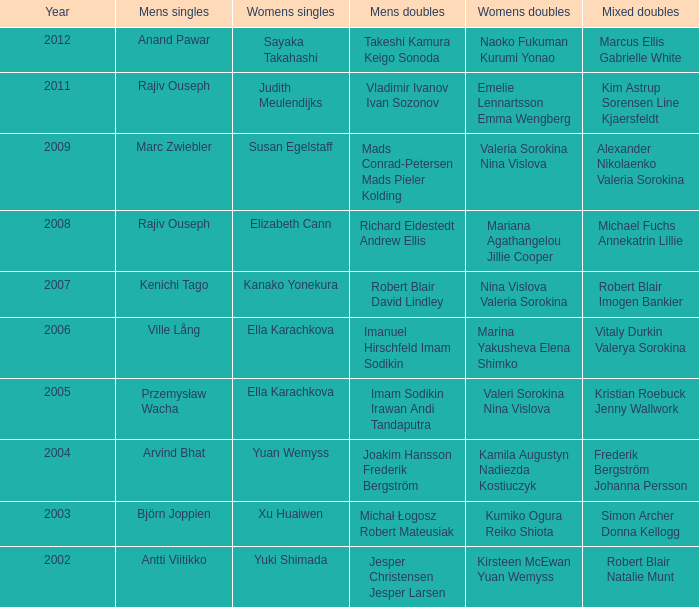What is the mens singles of 2008? Rajiv Ouseph. 